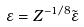<formula> <loc_0><loc_0><loc_500><loc_500>\varepsilon = Z ^ { - 1 / 8 } \tilde { \varepsilon }</formula> 